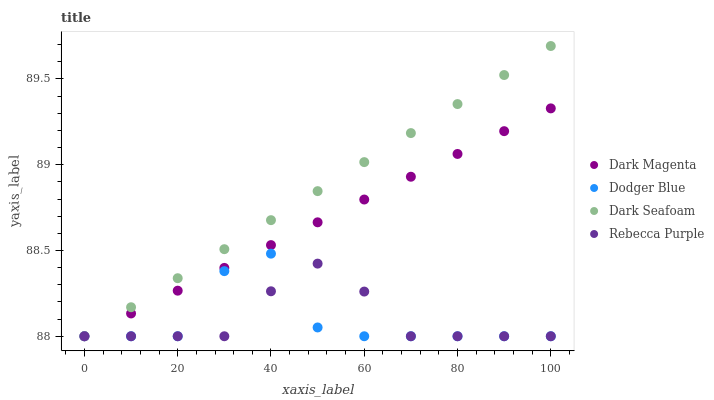Does Dodger Blue have the minimum area under the curve?
Answer yes or no. Yes. Does Dark Seafoam have the maximum area under the curve?
Answer yes or no. Yes. Does Dark Magenta have the minimum area under the curve?
Answer yes or no. No. Does Dark Magenta have the maximum area under the curve?
Answer yes or no. No. Is Dark Seafoam the smoothest?
Answer yes or no. Yes. Is Dodger Blue the roughest?
Answer yes or no. Yes. Is Dark Magenta the smoothest?
Answer yes or no. No. Is Dark Magenta the roughest?
Answer yes or no. No. Does Dark Seafoam have the lowest value?
Answer yes or no. Yes. Does Dark Seafoam have the highest value?
Answer yes or no. Yes. Does Dodger Blue have the highest value?
Answer yes or no. No. Does Dark Seafoam intersect Dark Magenta?
Answer yes or no. Yes. Is Dark Seafoam less than Dark Magenta?
Answer yes or no. No. Is Dark Seafoam greater than Dark Magenta?
Answer yes or no. No. 